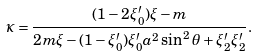Convert formula to latex. <formula><loc_0><loc_0><loc_500><loc_500>\kappa = \frac { ( 1 - 2 \xi ^ { \prime } _ { 0 } ) \xi - m } { 2 m \xi - ( 1 - \xi ^ { \prime } _ { 0 } ) \xi ^ { \prime } _ { 0 } a ^ { 2 } \sin ^ { 2 } \theta + \xi ^ { \prime } _ { 2 } \xi ^ { \prime } _ { 2 } } .</formula> 